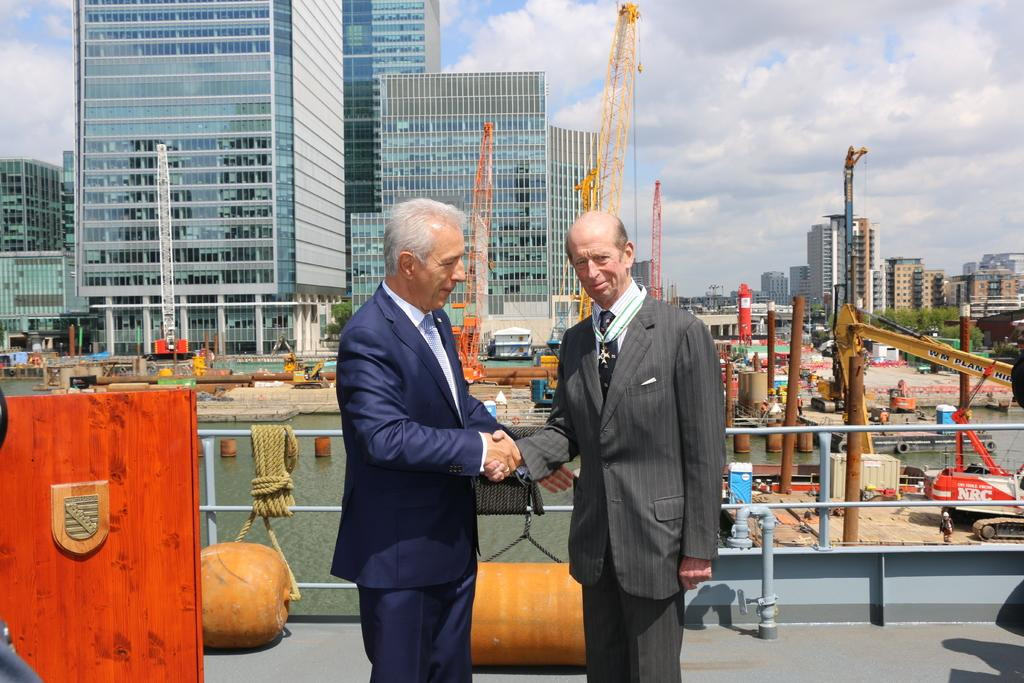How many people are in the image? There are two men in the image. Where are the men positioned in the image? The men are standing in the front. What are the men wearing? The men are wearing black suits. What are the men doing in the image? The men are shaking hands. What can be seen in the background of the image? There is a glass building in the background. What is visible in the sky in the image? The sky is visible in the image, and clouds are present. How many dolls are sitting on the lamp in the image? There are no dolls or lamps present in the image. What is the men's level of wealth based on their clothing in the image? The image does not provide information about the men's wealth, only that they are wearing black suits. 